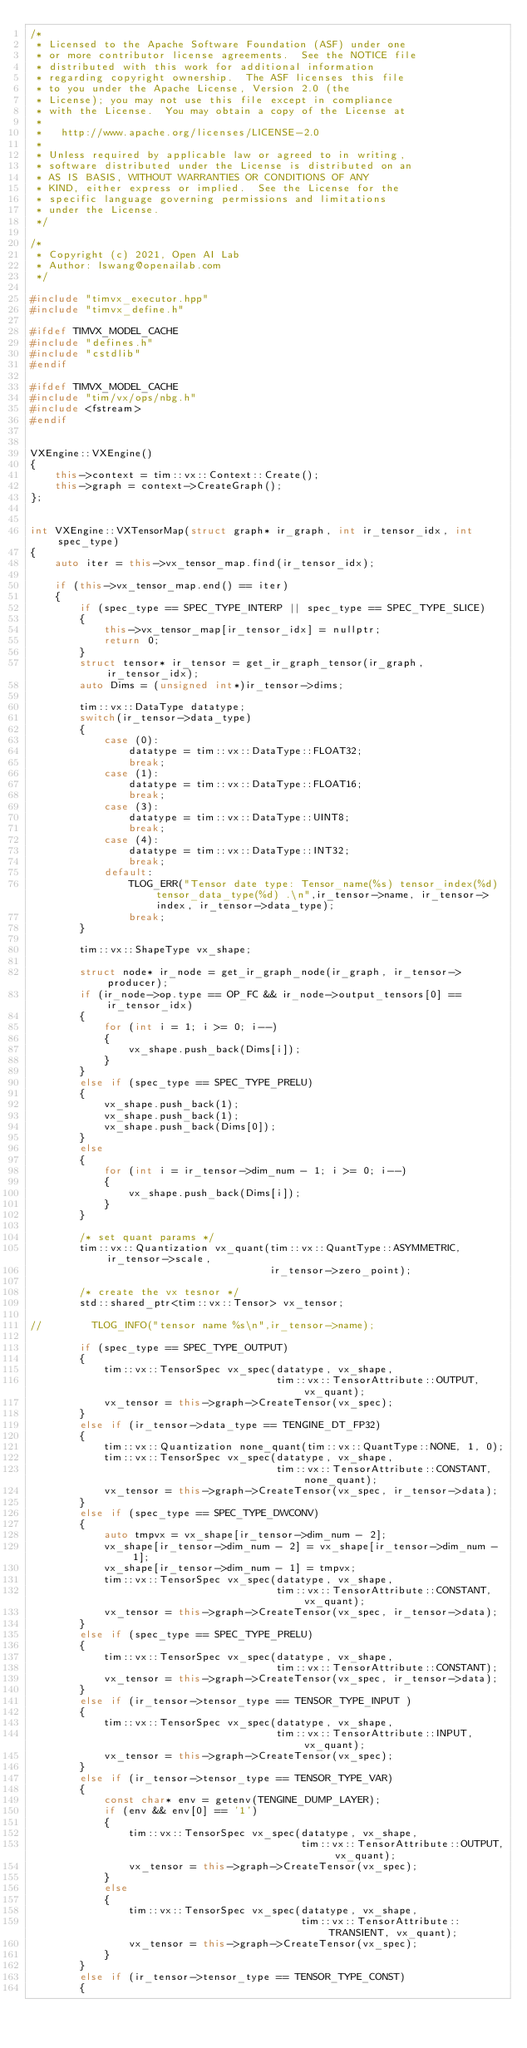<code> <loc_0><loc_0><loc_500><loc_500><_C++_>/*
 * Licensed to the Apache Software Foundation (ASF) under one
 * or more contributor license agreements.  See the NOTICE file
 * distributed with this work for additional information
 * regarding copyright ownership.  The ASF licenses this file
 * to you under the Apache License, Version 2.0 (the
 * License); you may not use this file except in compliance
 * with the License.  You may obtain a copy of the License at
 *
 *   http://www.apache.org/licenses/LICENSE-2.0
 *
 * Unless required by applicable law or agreed to in writing,
 * software distributed under the License is distributed on an
 * AS IS BASIS, WITHOUT WARRANTIES OR CONDITIONS OF ANY
 * KIND, either express or implied.  See the License for the
 * specific language governing permissions and limitations
 * under the License.
 */

/*
 * Copyright (c) 2021, Open AI Lab
 * Author: lswang@openailab.com
 */

#include "timvx_executor.hpp"
#include "timvx_define.h"

#ifdef TIMVX_MODEL_CACHE
#include "defines.h"
#include "cstdlib"
#endif

#ifdef TIMVX_MODEL_CACHE
#include "tim/vx/ops/nbg.h"
#include <fstream>
#endif


VXEngine::VXEngine()
{
    this->context = tim::vx::Context::Create();
    this->graph = context->CreateGraph();
};


int VXEngine::VXTensorMap(struct graph* ir_graph, int ir_tensor_idx, int spec_type)
{
    auto iter = this->vx_tensor_map.find(ir_tensor_idx);

    if (this->vx_tensor_map.end() == iter)
    {
        if (spec_type == SPEC_TYPE_INTERP || spec_type == SPEC_TYPE_SLICE)
        {
            this->vx_tensor_map[ir_tensor_idx] = nullptr;
            return 0;
        }
        struct tensor* ir_tensor = get_ir_graph_tensor(ir_graph, ir_tensor_idx);
        auto Dims = (unsigned int*)ir_tensor->dims;

        tim::vx::DataType datatype;
        switch(ir_tensor->data_type)
        {
            case (0):
                datatype = tim::vx::DataType::FLOAT32;
                break;
            case (1):
                datatype = tim::vx::DataType::FLOAT16;
                break;
            case (3):
                datatype = tim::vx::DataType::UINT8;
                break;
            case (4):
                datatype = tim::vx::DataType::INT32;
                break;
            default:
                TLOG_ERR("Tensor date type: Tensor_name(%s) tensor_index(%d) tensor_data_type(%d) .\n",ir_tensor->name, ir_tensor->index, ir_tensor->data_type);
                break;
        }

        tim::vx::ShapeType vx_shape;

        struct node* ir_node = get_ir_graph_node(ir_graph, ir_tensor->producer);
        if (ir_node->op.type == OP_FC && ir_node->output_tensors[0] == ir_tensor_idx)
        {
            for (int i = 1; i >= 0; i--)
            {
                vx_shape.push_back(Dims[i]);
            }
        }
        else if (spec_type == SPEC_TYPE_PRELU)
        {
            vx_shape.push_back(1);
            vx_shape.push_back(1);
            vx_shape.push_back(Dims[0]);
        }
        else
        {
            for (int i = ir_tensor->dim_num - 1; i >= 0; i--)
            {
                vx_shape.push_back(Dims[i]);
            }
        }

        /* set quant params */
        tim::vx::Quantization vx_quant(tim::vx::QuantType::ASYMMETRIC, ir_tensor->scale,
                                       ir_tensor->zero_point);

        /* create the vx tesnor */
        std::shared_ptr<tim::vx::Tensor> vx_tensor;

//        TLOG_INFO("tensor name %s\n",ir_tensor->name);

        if (spec_type == SPEC_TYPE_OUTPUT)
        {
            tim::vx::TensorSpec vx_spec(datatype, vx_shape,
                                        tim::vx::TensorAttribute::OUTPUT, vx_quant);
            vx_tensor = this->graph->CreateTensor(vx_spec);
        }
        else if (ir_tensor->data_type == TENGINE_DT_FP32)
        {
            tim::vx::Quantization none_quant(tim::vx::QuantType::NONE, 1, 0);
            tim::vx::TensorSpec vx_spec(datatype, vx_shape,
                                        tim::vx::TensorAttribute::CONSTANT, none_quant);
            vx_tensor = this->graph->CreateTensor(vx_spec, ir_tensor->data);
        }
        else if (spec_type == SPEC_TYPE_DWCONV)
        {
            auto tmpvx = vx_shape[ir_tensor->dim_num - 2];
            vx_shape[ir_tensor->dim_num - 2] = vx_shape[ir_tensor->dim_num - 1];
            vx_shape[ir_tensor->dim_num - 1] = tmpvx;
            tim::vx::TensorSpec vx_spec(datatype, vx_shape,
                                        tim::vx::TensorAttribute::CONSTANT, vx_quant);
            vx_tensor = this->graph->CreateTensor(vx_spec, ir_tensor->data);
        }
        else if (spec_type == SPEC_TYPE_PRELU)
        {
            tim::vx::TensorSpec vx_spec(datatype, vx_shape,
                                        tim::vx::TensorAttribute::CONSTANT);
            vx_tensor = this->graph->CreateTensor(vx_spec, ir_tensor->data);
        }
        else if (ir_tensor->tensor_type == TENSOR_TYPE_INPUT )
        {
            tim::vx::TensorSpec vx_spec(datatype, vx_shape,
                                        tim::vx::TensorAttribute::INPUT, vx_quant);
            vx_tensor = this->graph->CreateTensor(vx_spec);
        }
        else if (ir_tensor->tensor_type == TENSOR_TYPE_VAR)
        {
            const char* env = getenv(TENGINE_DUMP_LAYER);
            if (env && env[0] == '1')
            {
                tim::vx::TensorSpec vx_spec(datatype, vx_shape,
                                            tim::vx::TensorAttribute::OUTPUT, vx_quant);
                vx_tensor = this->graph->CreateTensor(vx_spec);
            }
            else
            {
                tim::vx::TensorSpec vx_spec(datatype, vx_shape,
                                            tim::vx::TensorAttribute::TRANSIENT, vx_quant);
                vx_tensor = this->graph->CreateTensor(vx_spec);
            }
        }
        else if (ir_tensor->tensor_type == TENSOR_TYPE_CONST)
        {</code> 